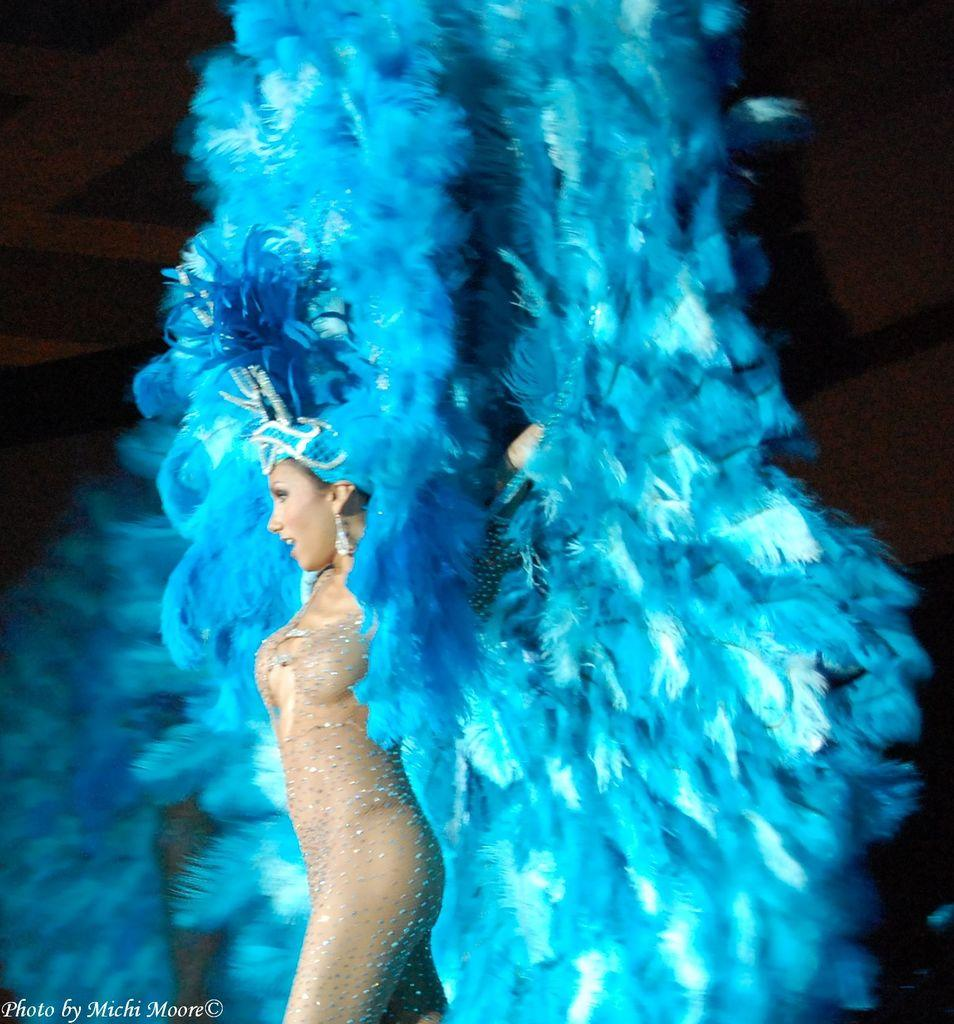Who is the main subject in the image? There is a woman in the image. What is the woman doing in the image? The woman is walking on a stage. What is the woman wearing in the image? The woman is wearing a decorated costume. What expression does the woman have in the image? The woman is smiling. What type of bird can be seen sitting on the woman's shoulder in the image? There is no bird present in the image; the woman is the main subject. 